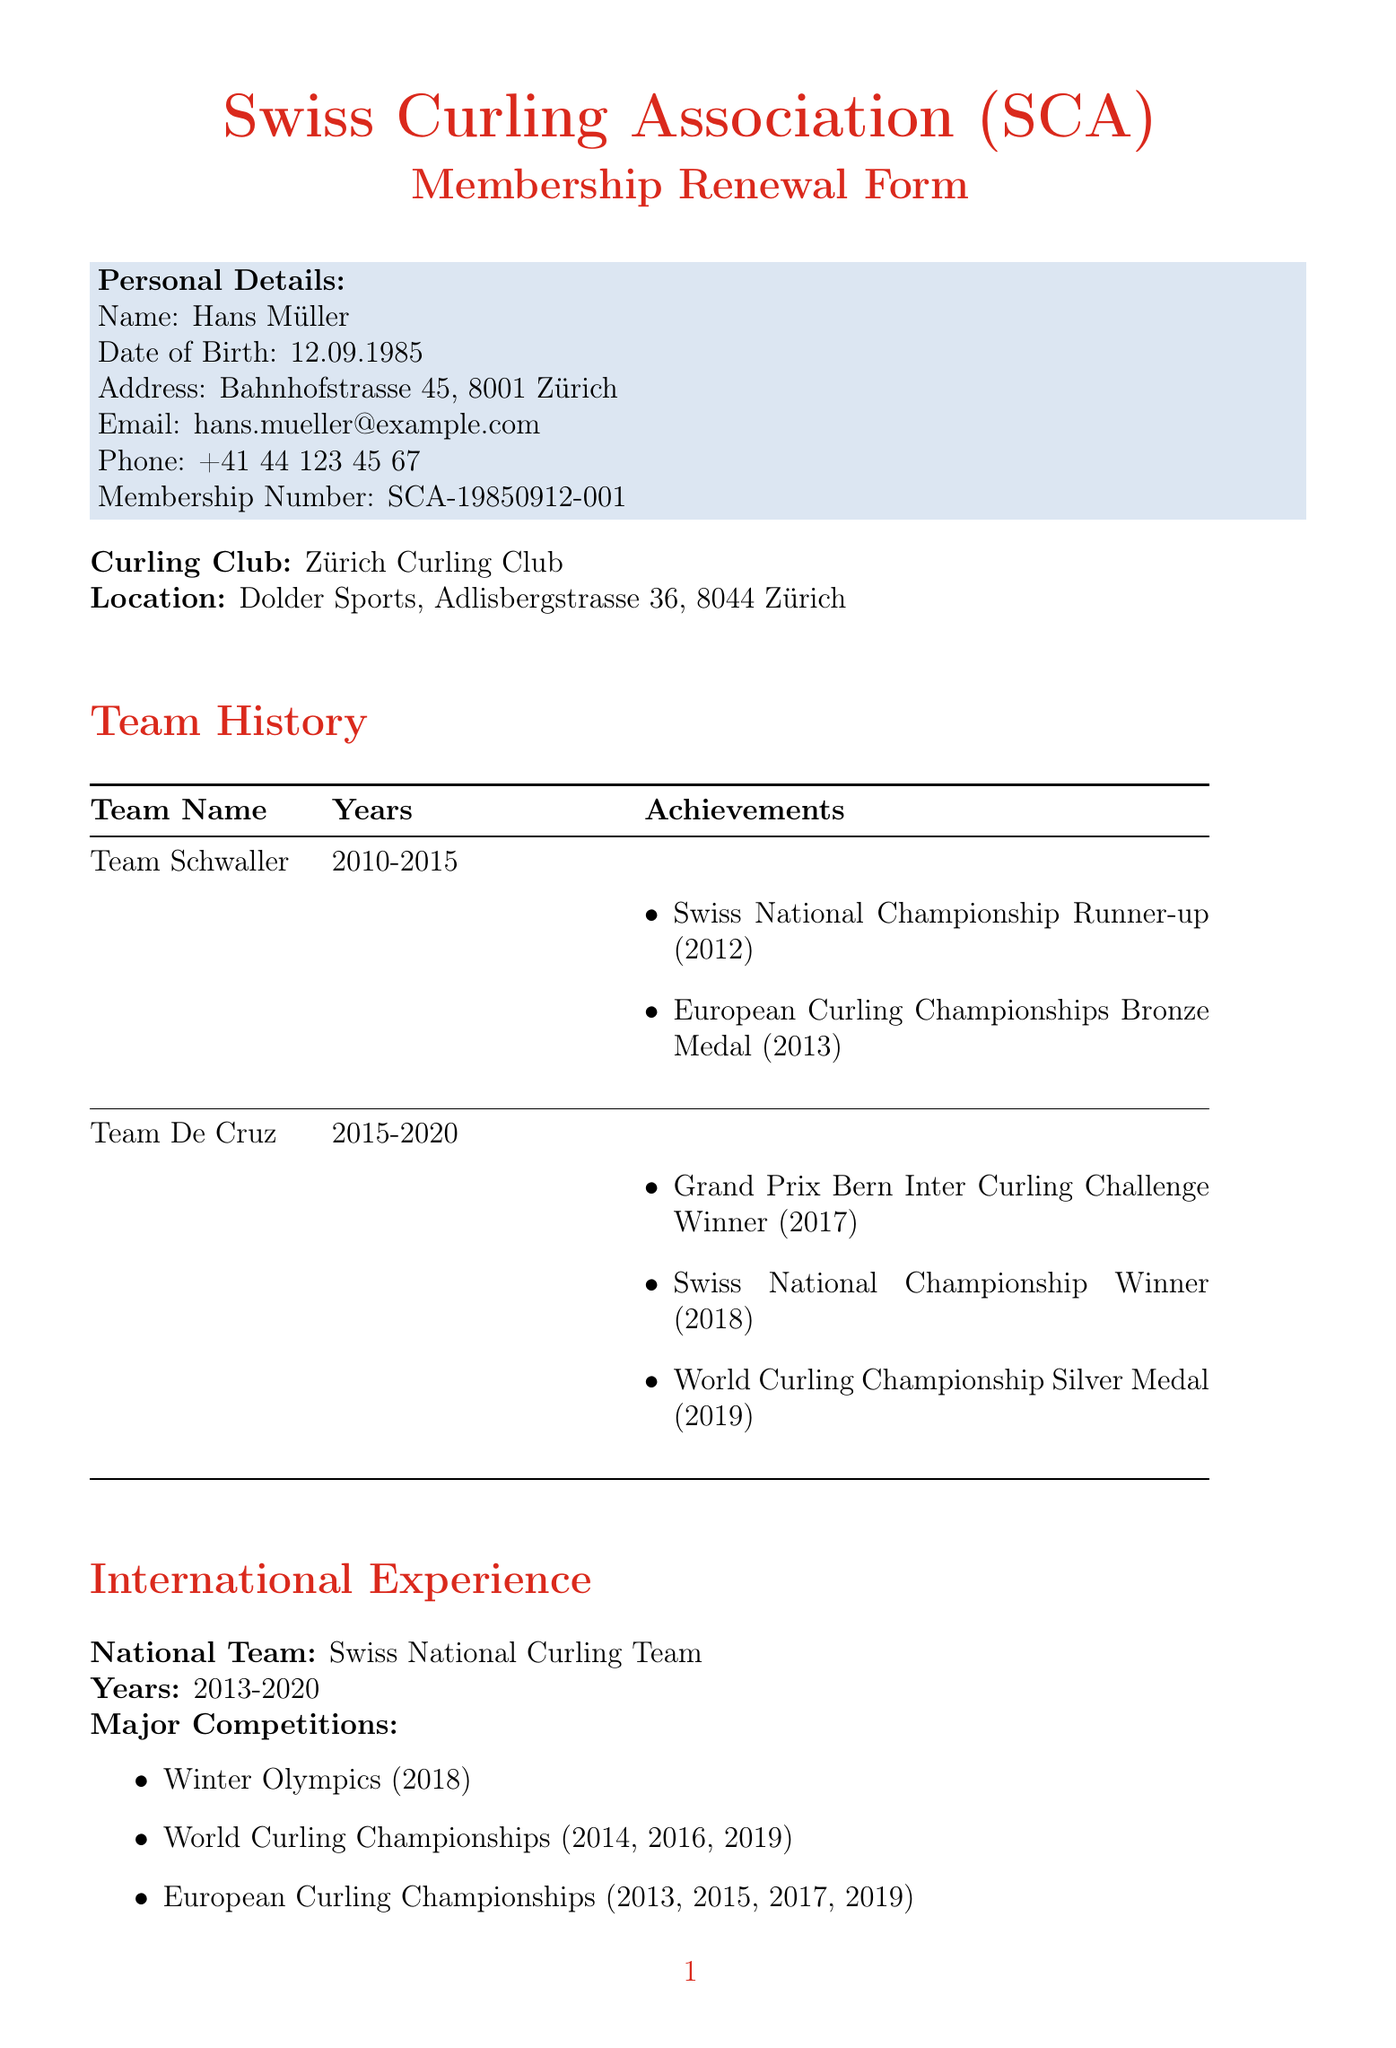what is the membership number? The membership number is provided in the personal details section of the document.
Answer: SCA-19850912-001 who is the contact person for membership? The contact person for membership is mentioned in the additional information section.
Answer: Martina Baumann what is the total amount for annual dues? The total amount for annual dues is summarized in the annual dues breakdown section.
Answer: 1600 which curling club is the member associated with? The curling club associated with the member is specified in the club section of the document.
Answer: Zürich Curling Club what years did Hans Müller play with Team De Cruz? The years Hans Müller was part of Team De Cruz are stated in the team history section.
Answer: 2015-2020 what is the renewal deadline for the membership? The renewal deadline is noted in the additional information section of the document.
Answer: 2023-08-31 how many major competitions did Hans Müller participate in with the national team? The number of major competitions is determined by counting the events listed in the international experience section.
Answer: 7 what payment method is accepted by credit card? Accepted credit card methods are listed in the payment options section of the document.
Answer: Visa, Mastercard, American Express 